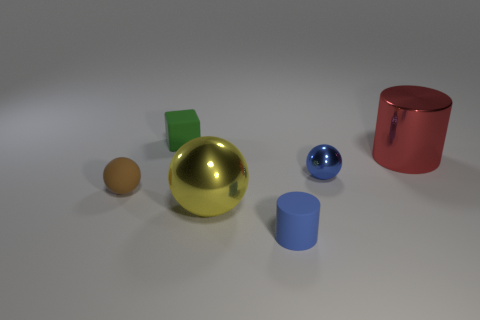Are there any other things that have the same shape as the tiny green thing?
Give a very brief answer. No. How many small cylinders are the same color as the tiny shiny thing?
Give a very brief answer. 1. Is the color of the cylinder that is in front of the large red thing the same as the small object that is to the right of the matte cylinder?
Keep it short and to the point. Yes. Do the small cylinder and the small shiny thing have the same color?
Your response must be concise. Yes. How many balls are both on the right side of the tiny green cube and in front of the tiny blue shiny sphere?
Your response must be concise. 1. What is the material of the red cylinder?
Keep it short and to the point. Metal. Are there any other things that are the same color as the big sphere?
Your response must be concise. No. Is the small block made of the same material as the blue cylinder?
Your answer should be very brief. Yes. What number of tiny rubber cylinders are on the left side of the object in front of the big metal object on the left side of the large red cylinder?
Keep it short and to the point. 0. How many big shiny balls are there?
Keep it short and to the point. 1. 